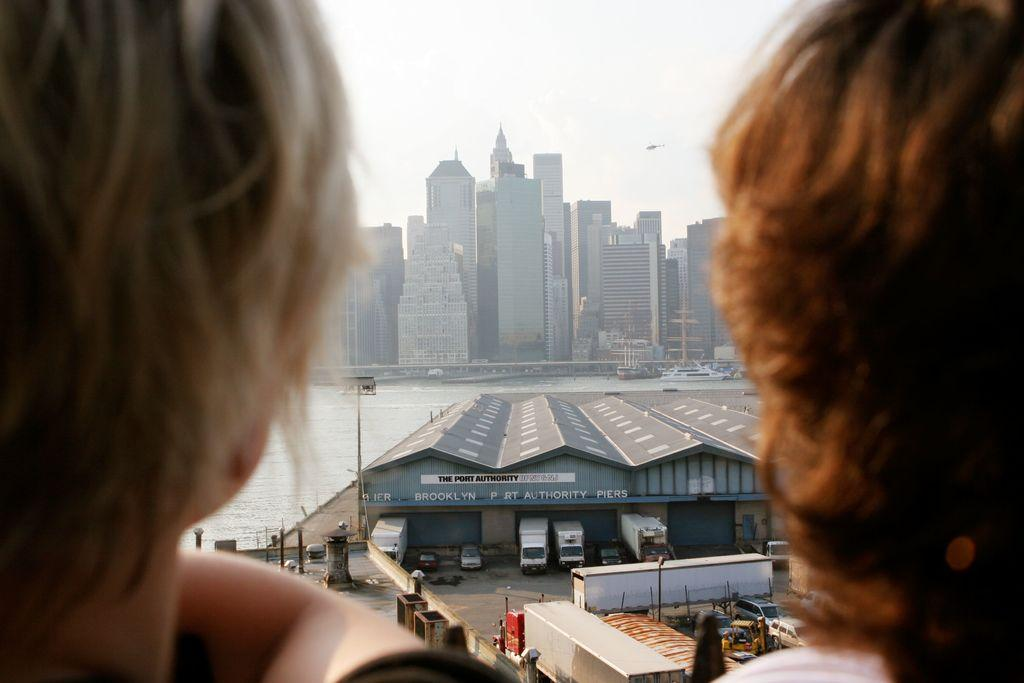Who or what can be seen in the image? There are people in the image. What can be seen in the distance behind the people? There are buildings, a shed, vehicles, water, boats, poles, and the sky visible in the background of the image. Can you describe the setting of the image? The image appears to be set near a body of water, with buildings, a shed, and vehicles in the background. What might be the purpose of the poles in the background? The poles in the background could be for various purposes, such as supporting power lines, streetlights, or signage. What type of pen is being used to draw on the ice in the image? There is no pen or ice present in the image; it features people, buildings, a shed, vehicles, water, boats, poles, and the sky. 